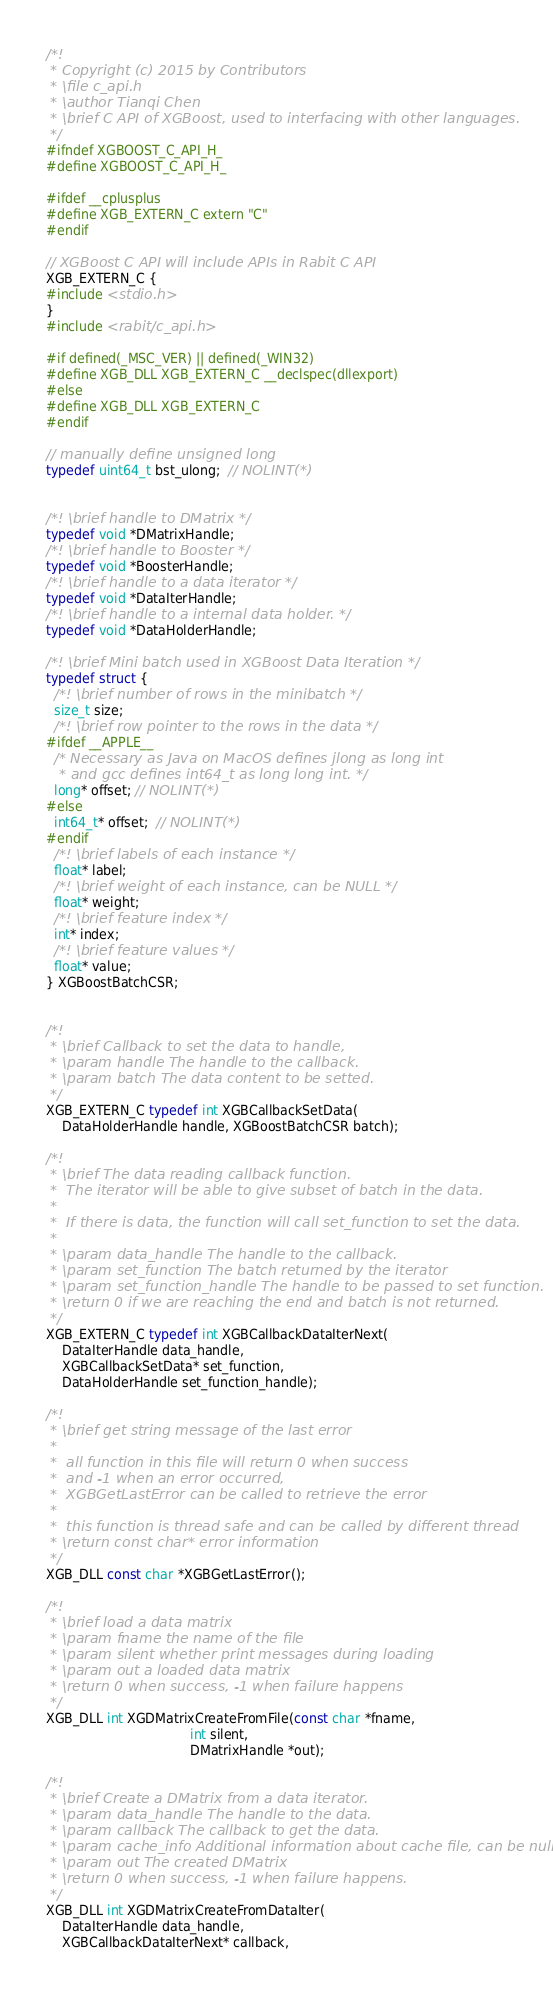<code> <loc_0><loc_0><loc_500><loc_500><_C_>/*!
 * Copyright (c) 2015 by Contributors
 * \file c_api.h
 * \author Tianqi Chen
 * \brief C API of XGBoost, used to interfacing with other languages.
 */
#ifndef XGBOOST_C_API_H_
#define XGBOOST_C_API_H_

#ifdef __cplusplus
#define XGB_EXTERN_C extern "C"
#endif

// XGBoost C API will include APIs in Rabit C API
XGB_EXTERN_C {
#include <stdio.h>
}
#include <rabit/c_api.h>

#if defined(_MSC_VER) || defined(_WIN32)
#define XGB_DLL XGB_EXTERN_C __declspec(dllexport)
#else
#define XGB_DLL XGB_EXTERN_C
#endif

// manually define unsigned long
typedef uint64_t bst_ulong;  // NOLINT(*)


/*! \brief handle to DMatrix */
typedef void *DMatrixHandle;
/*! \brief handle to Booster */
typedef void *BoosterHandle;
/*! \brief handle to a data iterator */
typedef void *DataIterHandle;
/*! \brief handle to a internal data holder. */
typedef void *DataHolderHandle;

/*! \brief Mini batch used in XGBoost Data Iteration */
typedef struct {
  /*! \brief number of rows in the minibatch */
  size_t size;
  /*! \brief row pointer to the rows in the data */
#ifdef __APPLE__
  /* Necessary as Java on MacOS defines jlong as long int
   * and gcc defines int64_t as long long int. */
  long* offset; // NOLINT(*)
#else
  int64_t* offset;  // NOLINT(*)
#endif
  /*! \brief labels of each instance */
  float* label;
  /*! \brief weight of each instance, can be NULL */
  float* weight;
  /*! \brief feature index */
  int* index;
  /*! \brief feature values */
  float* value;
} XGBoostBatchCSR;


/*!
 * \brief Callback to set the data to handle,
 * \param handle The handle to the callback.
 * \param batch The data content to be setted.
 */
XGB_EXTERN_C typedef int XGBCallbackSetData(
    DataHolderHandle handle, XGBoostBatchCSR batch);

/*!
 * \brief The data reading callback function.
 *  The iterator will be able to give subset of batch in the data.
 *
 *  If there is data, the function will call set_function to set the data.
 *
 * \param data_handle The handle to the callback.
 * \param set_function The batch returned by the iterator
 * \param set_function_handle The handle to be passed to set function.
 * \return 0 if we are reaching the end and batch is not returned.
 */
XGB_EXTERN_C typedef int XGBCallbackDataIterNext(
    DataIterHandle data_handle,
    XGBCallbackSetData* set_function,
    DataHolderHandle set_function_handle);

/*!
 * \brief get string message of the last error
 *
 *  all function in this file will return 0 when success
 *  and -1 when an error occurred,
 *  XGBGetLastError can be called to retrieve the error
 *
 *  this function is thread safe and can be called by different thread
 * \return const char* error information
 */
XGB_DLL const char *XGBGetLastError();

/*!
 * \brief load a data matrix
 * \param fname the name of the file
 * \param silent whether print messages during loading
 * \param out a loaded data matrix
 * \return 0 when success, -1 when failure happens
 */
XGB_DLL int XGDMatrixCreateFromFile(const char *fname,
                                    int silent,
                                    DMatrixHandle *out);

/*!
 * \brief Create a DMatrix from a data iterator.
 * \param data_handle The handle to the data.
 * \param callback The callback to get the data.
 * \param cache_info Additional information about cache file, can be null.
 * \param out The created DMatrix
 * \return 0 when success, -1 when failure happens.
 */
XGB_DLL int XGDMatrixCreateFromDataIter(
    DataIterHandle data_handle,
    XGBCallbackDataIterNext* callback,</code> 